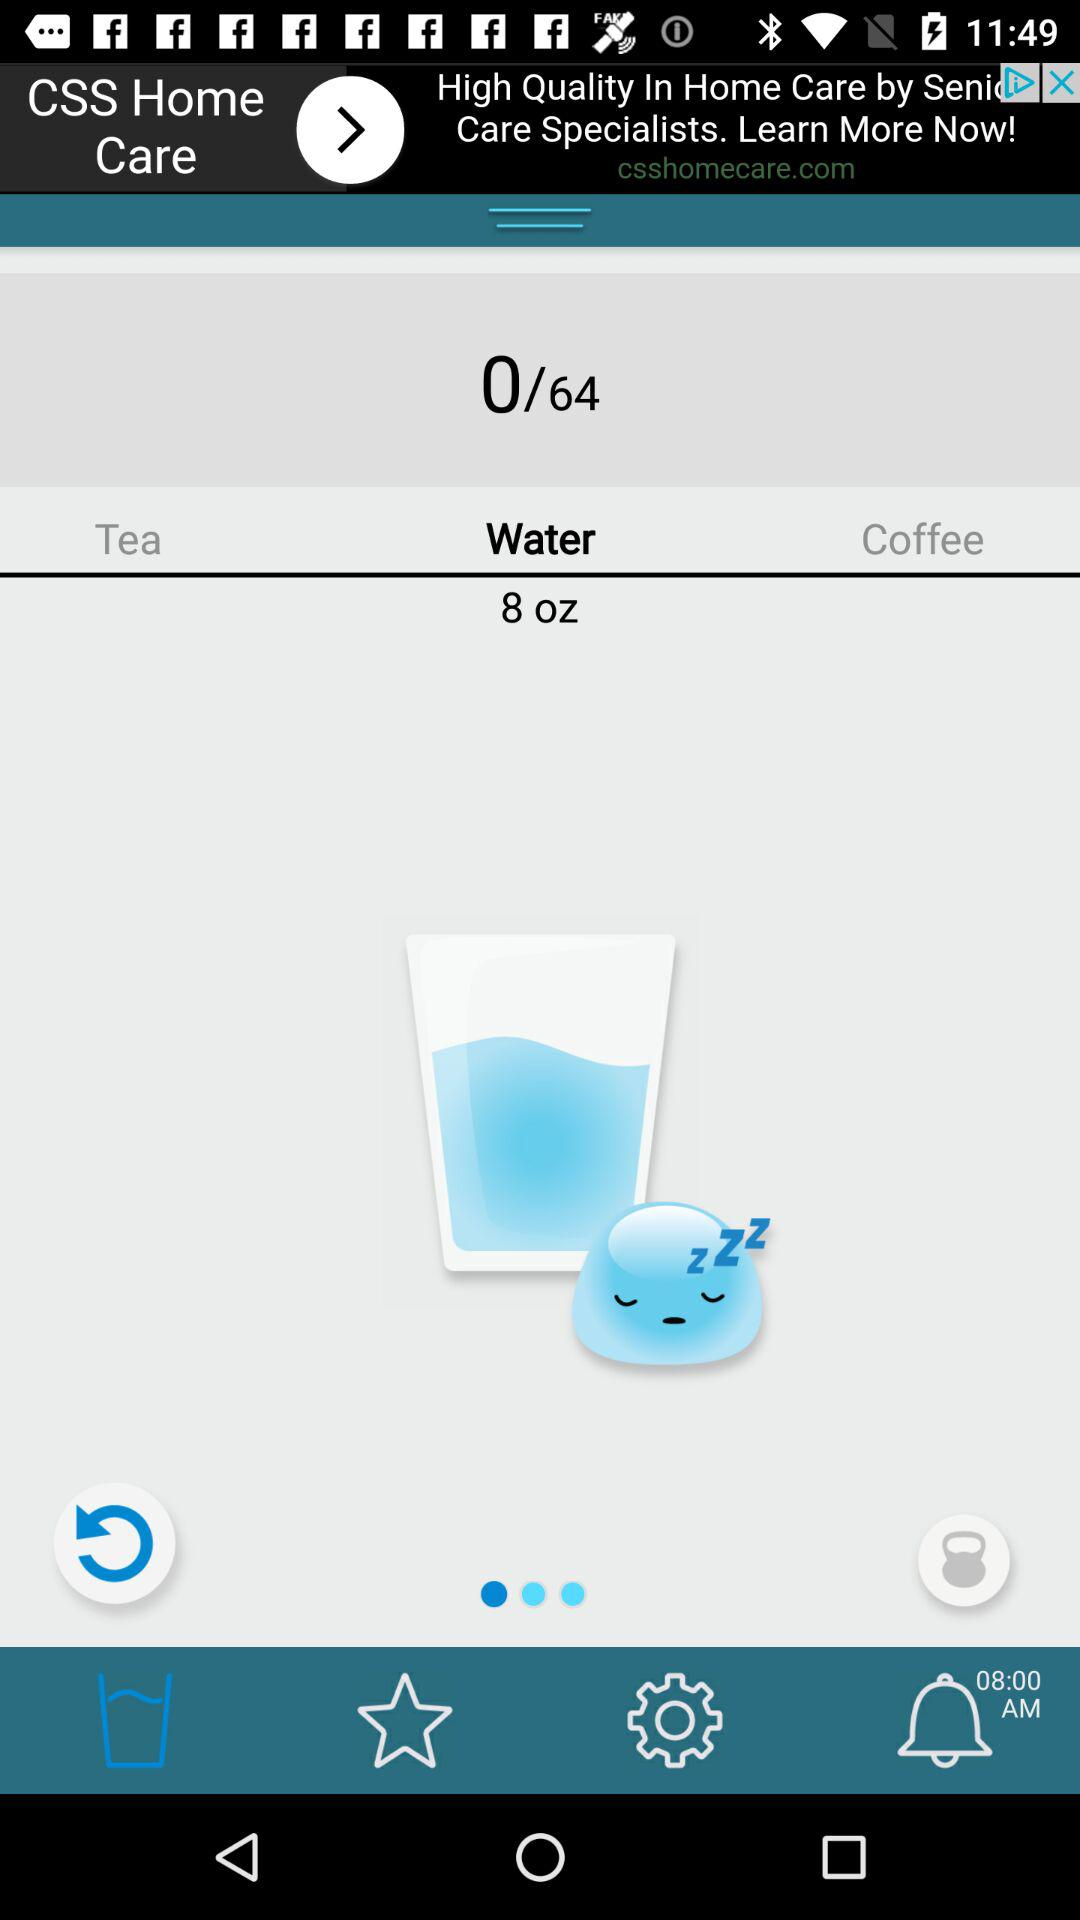What is the quantity of water? The quantity of water is 8 oz. 